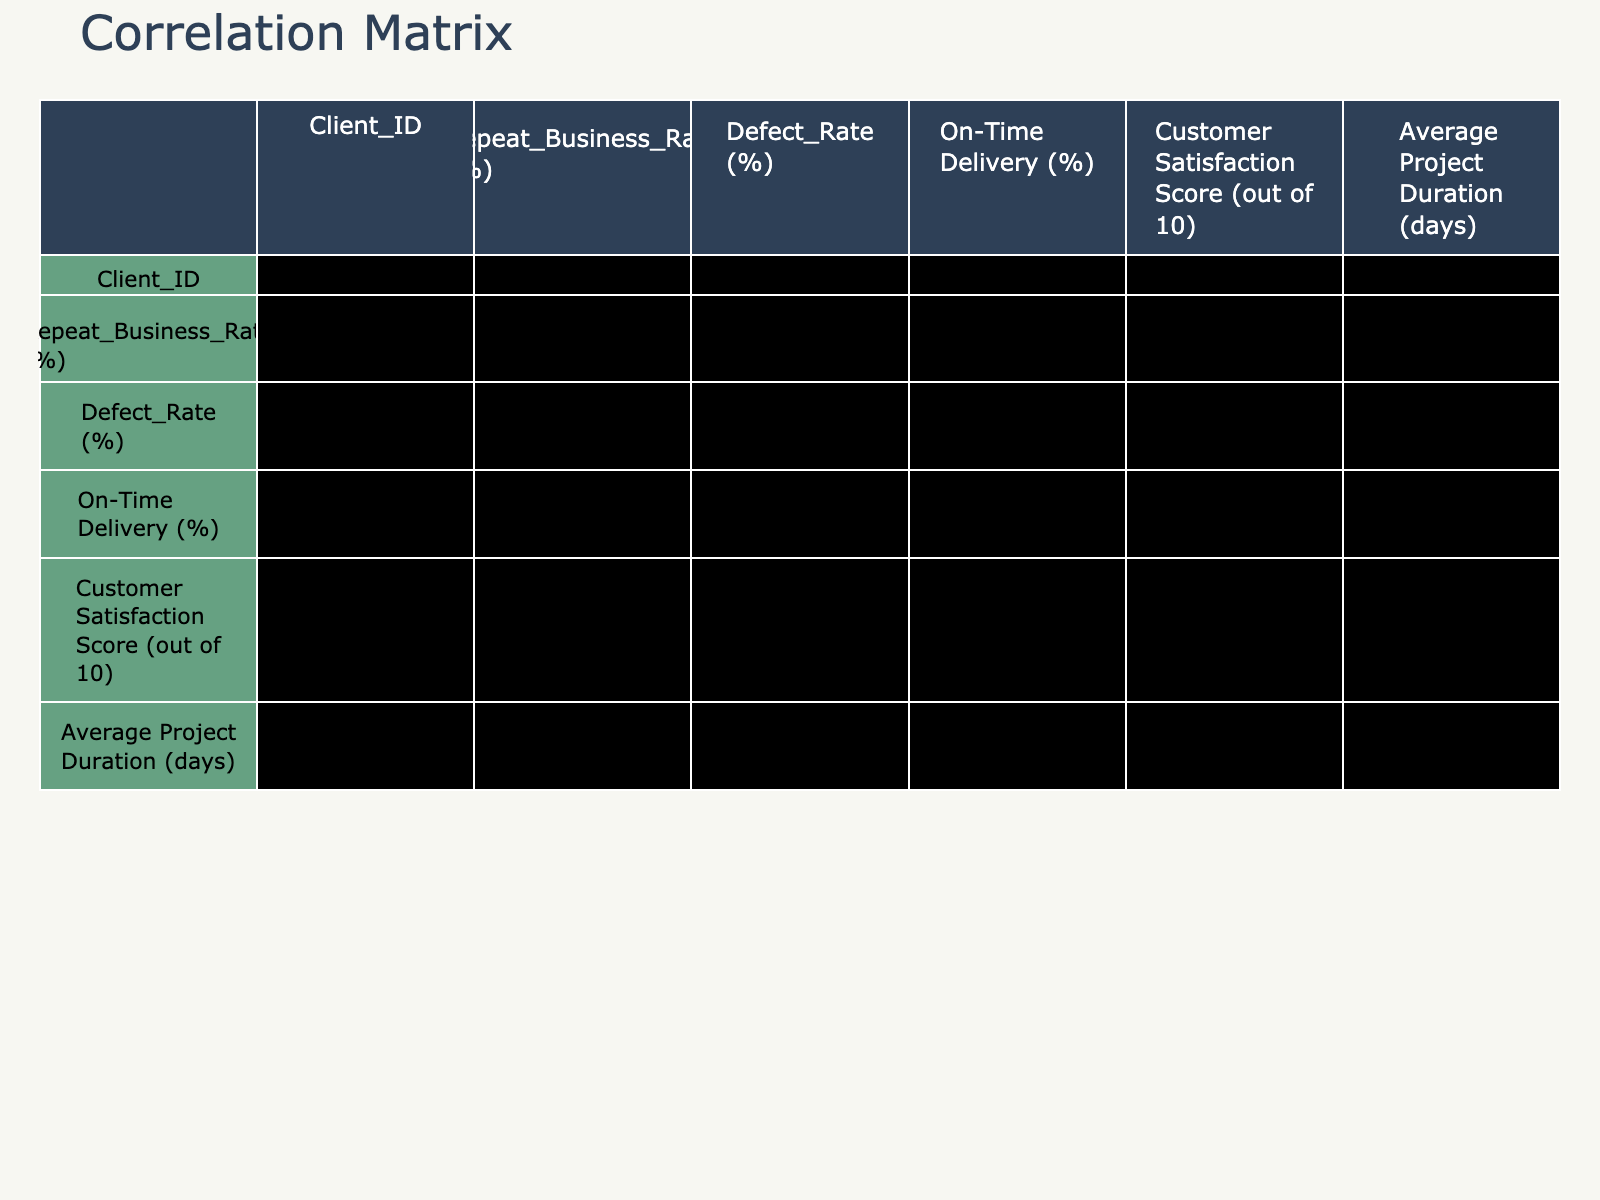What is the highest Repeat Business Rate? By examining the Repeat Business Rate column, we can see that the highest value is 90%, corresponding to Client_ID 7.
Answer: 90% What is the defect rate for the client with the lowest on-time delivery percentage? The lowest on-time delivery percentage is 75%, which corresponds to Client_ID 10. Looking at the Defect Rate for this client, it is 7%.
Answer: 7% Is there a client with a Repeat Business Rate over 80% and a Defect Rate below 3%? Clients with a Repeat Business Rate over 80% are Client_ID 1, 3, and 7. Only Client_ID 3 has a Defect Rate below 3%, which is 1%. Thus, the answer is yes.
Answer: Yes What is the average customer satisfaction score for clients with a Repeat Business Rate over 70%? We sum the Customer Satisfaction Scores for clients with a Repeat Business Rate over 70% (8.5, 9.0, 8.0, 9.5, 8.7) resulting in 43.7. There are 5 such clients, thus the average is 43.7/5 = 8.74.
Answer: 8.74 How does the average project duration for clients with a Defect Rate below 3% compare to those above 5%? Clients with Defect Rate below 3% are Client_ID 3 (28 days) and Client_ID 7 (25 days). Their average project duration is (28 + 25)/2 = 26.5 days. Clients with a Defect Rate above 5% are Client_ID 2, 4, 6, 8, and 10 (45, 50, 40, 55, 60 days). Their average is (45 + 50 + 40 + 55 + 60)/5 = 50 days. Comparing 26.5 days to 50 days shows that clients with lower defects generally have shorter project durations.
Answer: 26.5 days vs. 50 days Does a higher Customer Satisfaction Score correlate with a lower Defect Rate? Looking at the correlations in the table, the correlation coefficient between Customer Satisfaction Score and Defect Rate is negative (-0.80), suggesting that as the Customer Satisfaction Score increases, the Defect Rate tends to decrease.
Answer: Yes 